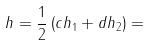Convert formula to latex. <formula><loc_0><loc_0><loc_500><loc_500>h = \frac { 1 } { 2 } \left ( c h _ { 1 } + d h _ { 2 } \right ) =</formula> 